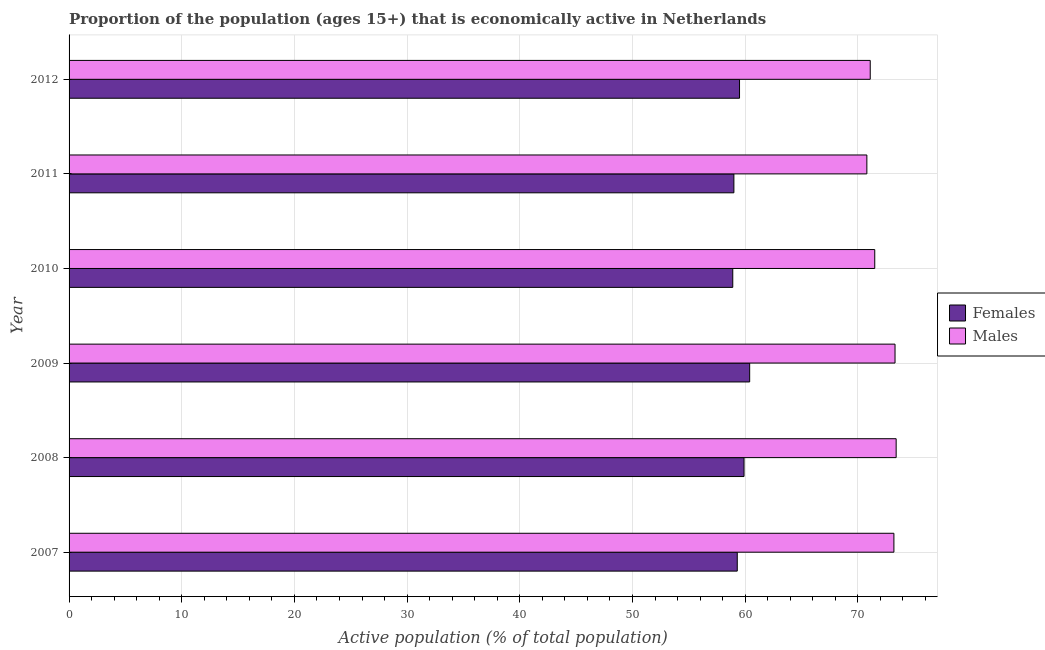How many different coloured bars are there?
Provide a succinct answer. 2. How many bars are there on the 5th tick from the top?
Give a very brief answer. 2. What is the label of the 4th group of bars from the top?
Your response must be concise. 2009. In how many cases, is the number of bars for a given year not equal to the number of legend labels?
Give a very brief answer. 0. What is the percentage of economically active female population in 2008?
Your answer should be compact. 59.9. Across all years, what is the maximum percentage of economically active female population?
Make the answer very short. 60.4. Across all years, what is the minimum percentage of economically active female population?
Your answer should be very brief. 58.9. What is the total percentage of economically active male population in the graph?
Your answer should be compact. 433.3. What is the difference between the percentage of economically active female population in 2009 and the percentage of economically active male population in 2008?
Give a very brief answer. -13. What is the average percentage of economically active male population per year?
Keep it short and to the point. 72.22. In the year 2010, what is the difference between the percentage of economically active female population and percentage of economically active male population?
Provide a succinct answer. -12.6. In how many years, is the percentage of economically active male population greater than 54 %?
Ensure brevity in your answer.  6. What is the ratio of the percentage of economically active female population in 2008 to that in 2012?
Keep it short and to the point. 1.01. Is the percentage of economically active male population in 2007 less than that in 2009?
Keep it short and to the point. Yes. Is the difference between the percentage of economically active female population in 2010 and 2011 greater than the difference between the percentage of economically active male population in 2010 and 2011?
Your answer should be very brief. No. What does the 1st bar from the top in 2008 represents?
Offer a very short reply. Males. What does the 2nd bar from the bottom in 2009 represents?
Your answer should be very brief. Males. What is the difference between two consecutive major ticks on the X-axis?
Your answer should be compact. 10. Are the values on the major ticks of X-axis written in scientific E-notation?
Your answer should be very brief. No. What is the title of the graph?
Your answer should be compact. Proportion of the population (ages 15+) that is economically active in Netherlands. Does "Female population" appear as one of the legend labels in the graph?
Offer a very short reply. No. What is the label or title of the X-axis?
Keep it short and to the point. Active population (% of total population). What is the Active population (% of total population) of Females in 2007?
Offer a very short reply. 59.3. What is the Active population (% of total population) in Males in 2007?
Make the answer very short. 73.2. What is the Active population (% of total population) in Females in 2008?
Ensure brevity in your answer.  59.9. What is the Active population (% of total population) of Males in 2008?
Your answer should be compact. 73.4. What is the Active population (% of total population) of Females in 2009?
Offer a terse response. 60.4. What is the Active population (% of total population) of Males in 2009?
Make the answer very short. 73.3. What is the Active population (% of total population) of Females in 2010?
Keep it short and to the point. 58.9. What is the Active population (% of total population) in Males in 2010?
Make the answer very short. 71.5. What is the Active population (% of total population) in Females in 2011?
Keep it short and to the point. 59. What is the Active population (% of total population) in Males in 2011?
Your answer should be compact. 70.8. What is the Active population (% of total population) of Females in 2012?
Your answer should be very brief. 59.5. What is the Active population (% of total population) in Males in 2012?
Offer a terse response. 71.1. Across all years, what is the maximum Active population (% of total population) of Females?
Provide a short and direct response. 60.4. Across all years, what is the maximum Active population (% of total population) of Males?
Give a very brief answer. 73.4. Across all years, what is the minimum Active population (% of total population) in Females?
Make the answer very short. 58.9. Across all years, what is the minimum Active population (% of total population) of Males?
Your answer should be compact. 70.8. What is the total Active population (% of total population) of Females in the graph?
Offer a terse response. 357. What is the total Active population (% of total population) of Males in the graph?
Ensure brevity in your answer.  433.3. What is the difference between the Active population (% of total population) of Females in 2007 and that in 2010?
Ensure brevity in your answer.  0.4. What is the difference between the Active population (% of total population) in Males in 2007 and that in 2010?
Offer a terse response. 1.7. What is the difference between the Active population (% of total population) of Males in 2007 and that in 2011?
Make the answer very short. 2.4. What is the difference between the Active population (% of total population) in Females in 2007 and that in 2012?
Provide a short and direct response. -0.2. What is the difference between the Active population (% of total population) of Males in 2008 and that in 2010?
Ensure brevity in your answer.  1.9. What is the difference between the Active population (% of total population) in Females in 2008 and that in 2011?
Provide a short and direct response. 0.9. What is the difference between the Active population (% of total population) in Males in 2008 and that in 2011?
Your answer should be compact. 2.6. What is the difference between the Active population (% of total population) of Females in 2008 and that in 2012?
Keep it short and to the point. 0.4. What is the difference between the Active population (% of total population) of Males in 2008 and that in 2012?
Give a very brief answer. 2.3. What is the difference between the Active population (% of total population) of Females in 2009 and that in 2011?
Offer a terse response. 1.4. What is the difference between the Active population (% of total population) in Females in 2010 and that in 2011?
Offer a very short reply. -0.1. What is the difference between the Active population (% of total population) in Males in 2010 and that in 2011?
Provide a short and direct response. 0.7. What is the difference between the Active population (% of total population) of Females in 2010 and that in 2012?
Offer a very short reply. -0.6. What is the difference between the Active population (% of total population) of Males in 2010 and that in 2012?
Keep it short and to the point. 0.4. What is the difference between the Active population (% of total population) of Males in 2011 and that in 2012?
Your answer should be very brief. -0.3. What is the difference between the Active population (% of total population) in Females in 2007 and the Active population (% of total population) in Males in 2008?
Your response must be concise. -14.1. What is the difference between the Active population (% of total population) of Females in 2007 and the Active population (% of total population) of Males in 2011?
Ensure brevity in your answer.  -11.5. What is the difference between the Active population (% of total population) of Females in 2008 and the Active population (% of total population) of Males in 2009?
Ensure brevity in your answer.  -13.4. What is the difference between the Active population (% of total population) in Females in 2008 and the Active population (% of total population) in Males in 2010?
Offer a very short reply. -11.6. What is the difference between the Active population (% of total population) in Females in 2009 and the Active population (% of total population) in Males in 2010?
Offer a very short reply. -11.1. What is the difference between the Active population (% of total population) in Females in 2010 and the Active population (% of total population) in Males in 2011?
Make the answer very short. -11.9. What is the difference between the Active population (% of total population) in Females in 2010 and the Active population (% of total population) in Males in 2012?
Ensure brevity in your answer.  -12.2. What is the average Active population (% of total population) in Females per year?
Your answer should be very brief. 59.5. What is the average Active population (% of total population) of Males per year?
Ensure brevity in your answer.  72.22. In the year 2008, what is the difference between the Active population (% of total population) in Females and Active population (% of total population) in Males?
Make the answer very short. -13.5. In the year 2009, what is the difference between the Active population (% of total population) in Females and Active population (% of total population) in Males?
Offer a terse response. -12.9. In the year 2012, what is the difference between the Active population (% of total population) of Females and Active population (% of total population) of Males?
Provide a short and direct response. -11.6. What is the ratio of the Active population (% of total population) in Males in 2007 to that in 2008?
Ensure brevity in your answer.  1. What is the ratio of the Active population (% of total population) of Females in 2007 to that in 2009?
Your response must be concise. 0.98. What is the ratio of the Active population (% of total population) in Males in 2007 to that in 2009?
Ensure brevity in your answer.  1. What is the ratio of the Active population (% of total population) of Females in 2007 to that in 2010?
Your answer should be very brief. 1.01. What is the ratio of the Active population (% of total population) of Males in 2007 to that in 2010?
Your answer should be compact. 1.02. What is the ratio of the Active population (% of total population) of Males in 2007 to that in 2011?
Ensure brevity in your answer.  1.03. What is the ratio of the Active population (% of total population) of Females in 2007 to that in 2012?
Your answer should be compact. 1. What is the ratio of the Active population (% of total population) of Males in 2007 to that in 2012?
Your response must be concise. 1.03. What is the ratio of the Active population (% of total population) of Males in 2008 to that in 2010?
Offer a very short reply. 1.03. What is the ratio of the Active population (% of total population) in Females in 2008 to that in 2011?
Your answer should be very brief. 1.02. What is the ratio of the Active population (% of total population) in Males in 2008 to that in 2011?
Keep it short and to the point. 1.04. What is the ratio of the Active population (% of total population) of Females in 2008 to that in 2012?
Offer a terse response. 1.01. What is the ratio of the Active population (% of total population) in Males in 2008 to that in 2012?
Offer a terse response. 1.03. What is the ratio of the Active population (% of total population) in Females in 2009 to that in 2010?
Ensure brevity in your answer.  1.03. What is the ratio of the Active population (% of total population) of Males in 2009 to that in 2010?
Provide a short and direct response. 1.03. What is the ratio of the Active population (% of total population) in Females in 2009 to that in 2011?
Offer a very short reply. 1.02. What is the ratio of the Active population (% of total population) of Males in 2009 to that in 2011?
Provide a succinct answer. 1.04. What is the ratio of the Active population (% of total population) of Females in 2009 to that in 2012?
Ensure brevity in your answer.  1.02. What is the ratio of the Active population (% of total population) of Males in 2009 to that in 2012?
Offer a very short reply. 1.03. What is the ratio of the Active population (% of total population) in Females in 2010 to that in 2011?
Ensure brevity in your answer.  1. What is the ratio of the Active population (% of total population) of Males in 2010 to that in 2011?
Offer a terse response. 1.01. What is the ratio of the Active population (% of total population) in Females in 2010 to that in 2012?
Make the answer very short. 0.99. What is the ratio of the Active population (% of total population) of Males in 2010 to that in 2012?
Provide a succinct answer. 1.01. What is the difference between the highest and the second highest Active population (% of total population) of Females?
Make the answer very short. 0.5. What is the difference between the highest and the lowest Active population (% of total population) of Males?
Offer a very short reply. 2.6. 